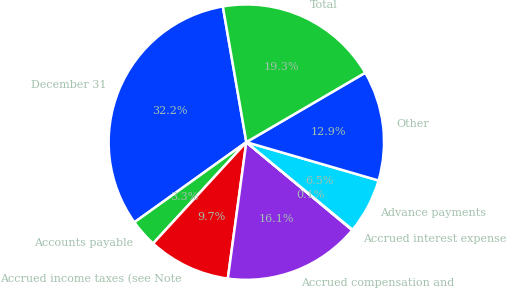Convert chart. <chart><loc_0><loc_0><loc_500><loc_500><pie_chart><fcel>December 31<fcel>Accounts payable<fcel>Accrued income taxes (see Note<fcel>Accrued compensation and<fcel>Accrued interest expense<fcel>Advance payments<fcel>Other<fcel>Total<nl><fcel>32.16%<fcel>3.27%<fcel>9.69%<fcel>16.11%<fcel>0.06%<fcel>6.48%<fcel>12.9%<fcel>19.32%<nl></chart> 